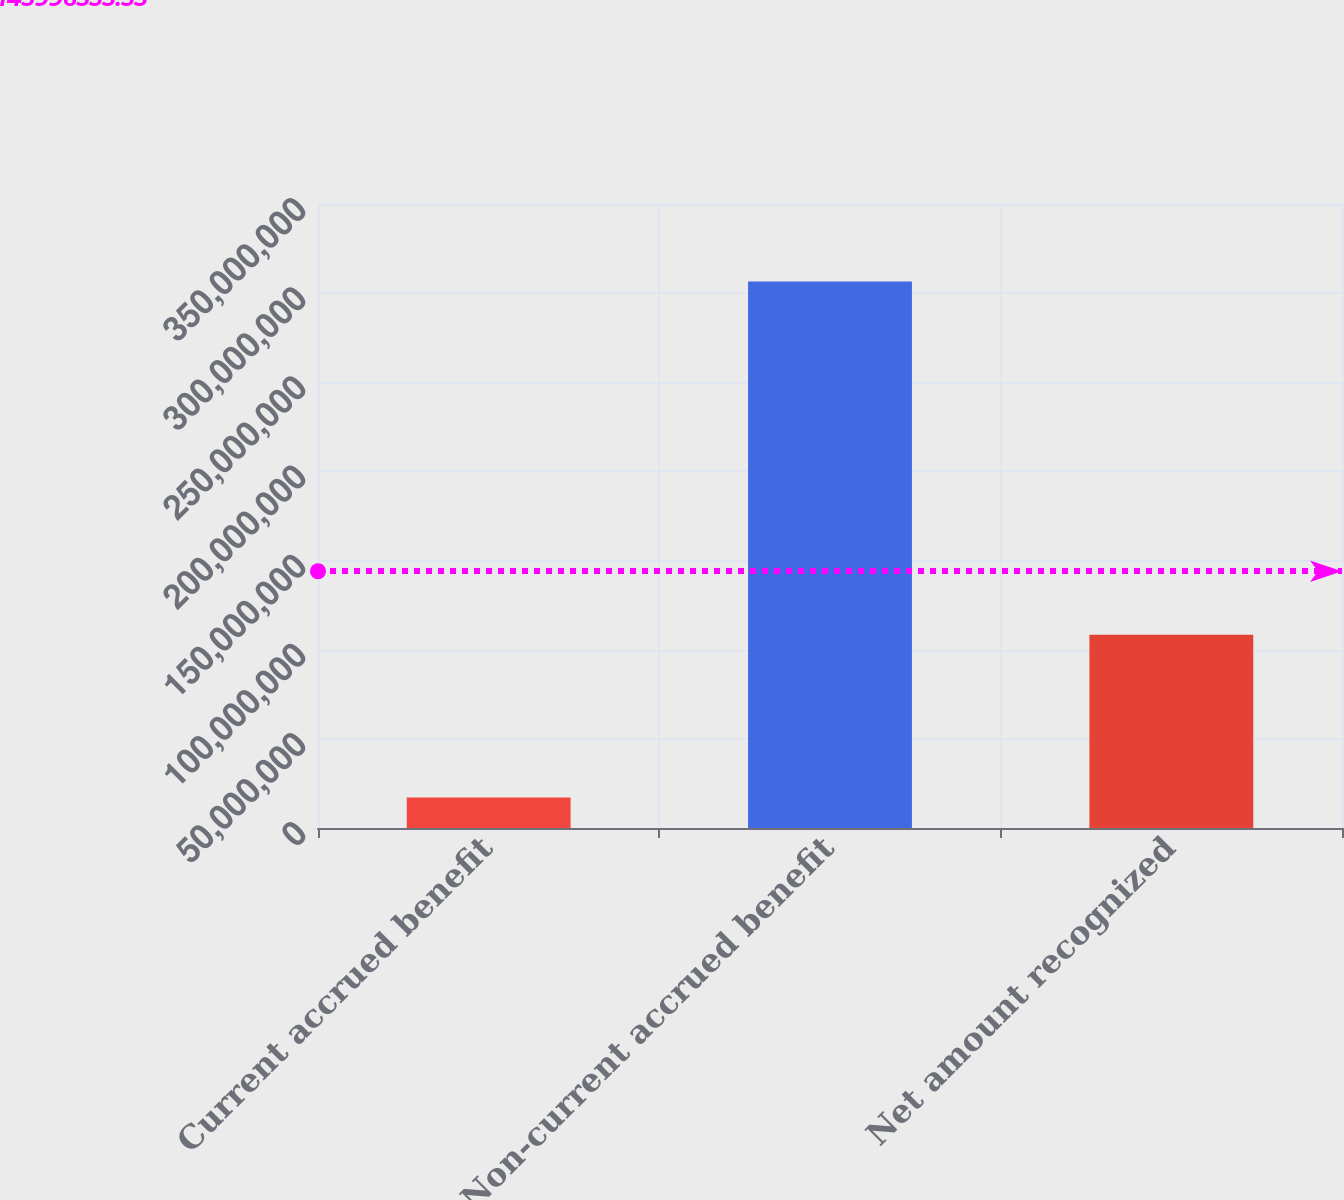<chart> <loc_0><loc_0><loc_500><loc_500><bar_chart><fcel>Current accrued benefit<fcel>Non-current accrued benefit<fcel>Net amount recognized<nl><fcel>1.7082e+07<fcel>3.06492e+08<fcel>1.08415e+08<nl></chart> 